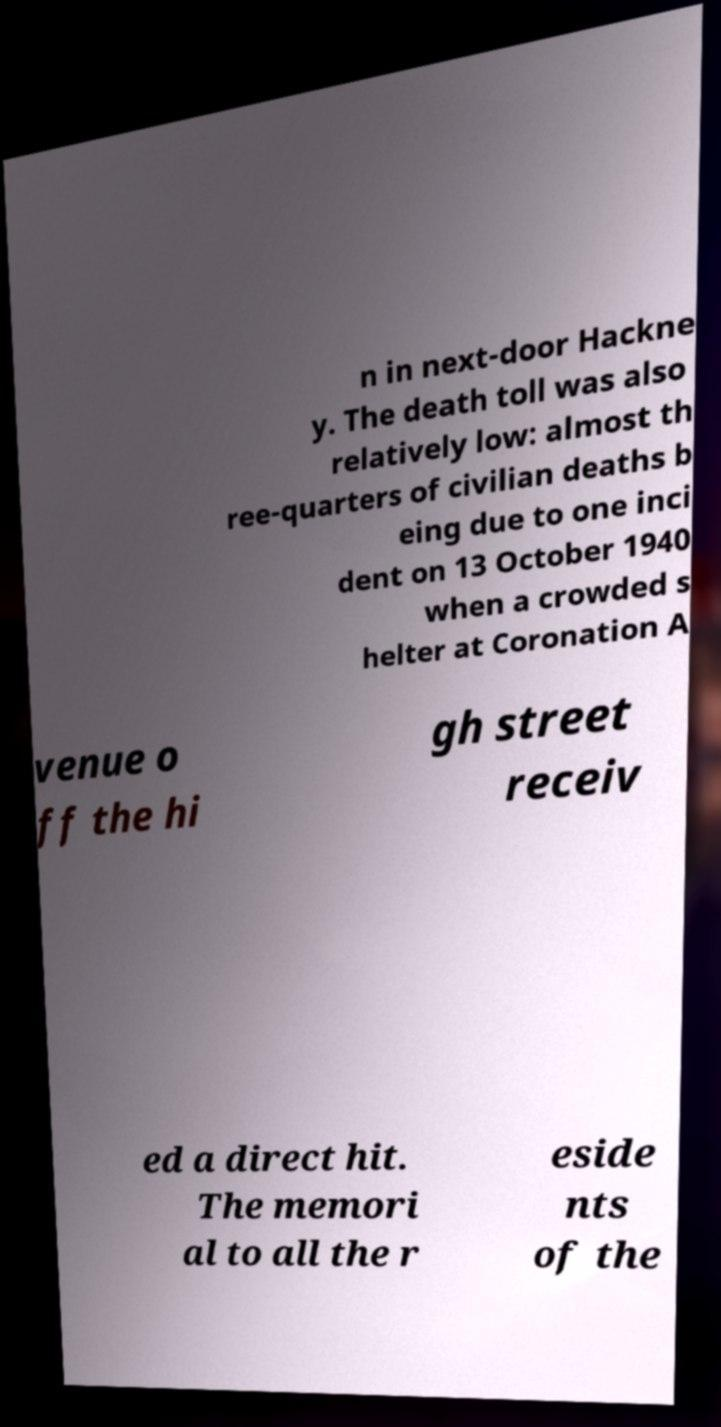Please identify and transcribe the text found in this image. n in next-door Hackne y. The death toll was also relatively low: almost th ree-quarters of civilian deaths b eing due to one inci dent on 13 October 1940 when a crowded s helter at Coronation A venue o ff the hi gh street receiv ed a direct hit. The memori al to all the r eside nts of the 